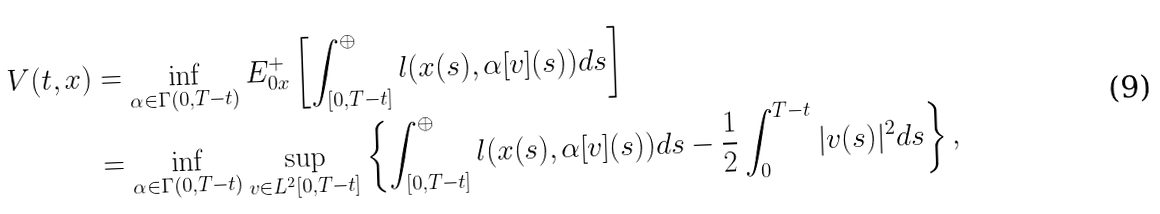Convert formula to latex. <formula><loc_0><loc_0><loc_500><loc_500>V ( t , x ) & = \inf _ { \alpha \in \Gamma ( 0 , T - t ) } E ^ { + } _ { 0 x } \left [ \int _ { [ 0 , T - t ] } ^ { \oplus } l ( x ( s ) , \alpha [ v ] ( s ) ) d s \right ] \\ & = \inf _ { \alpha \in \Gamma ( 0 , T - t ) } \sup _ { v \in L ^ { 2 } [ 0 , T - t ] } \left \{ \int _ { [ 0 , T - t ] } ^ { \oplus } l ( x ( s ) , \alpha [ v ] ( s ) ) d s - \frac { 1 } { 2 } \int _ { 0 } ^ { T - t } | v ( s ) | ^ { 2 } d s \right \} ,</formula> 